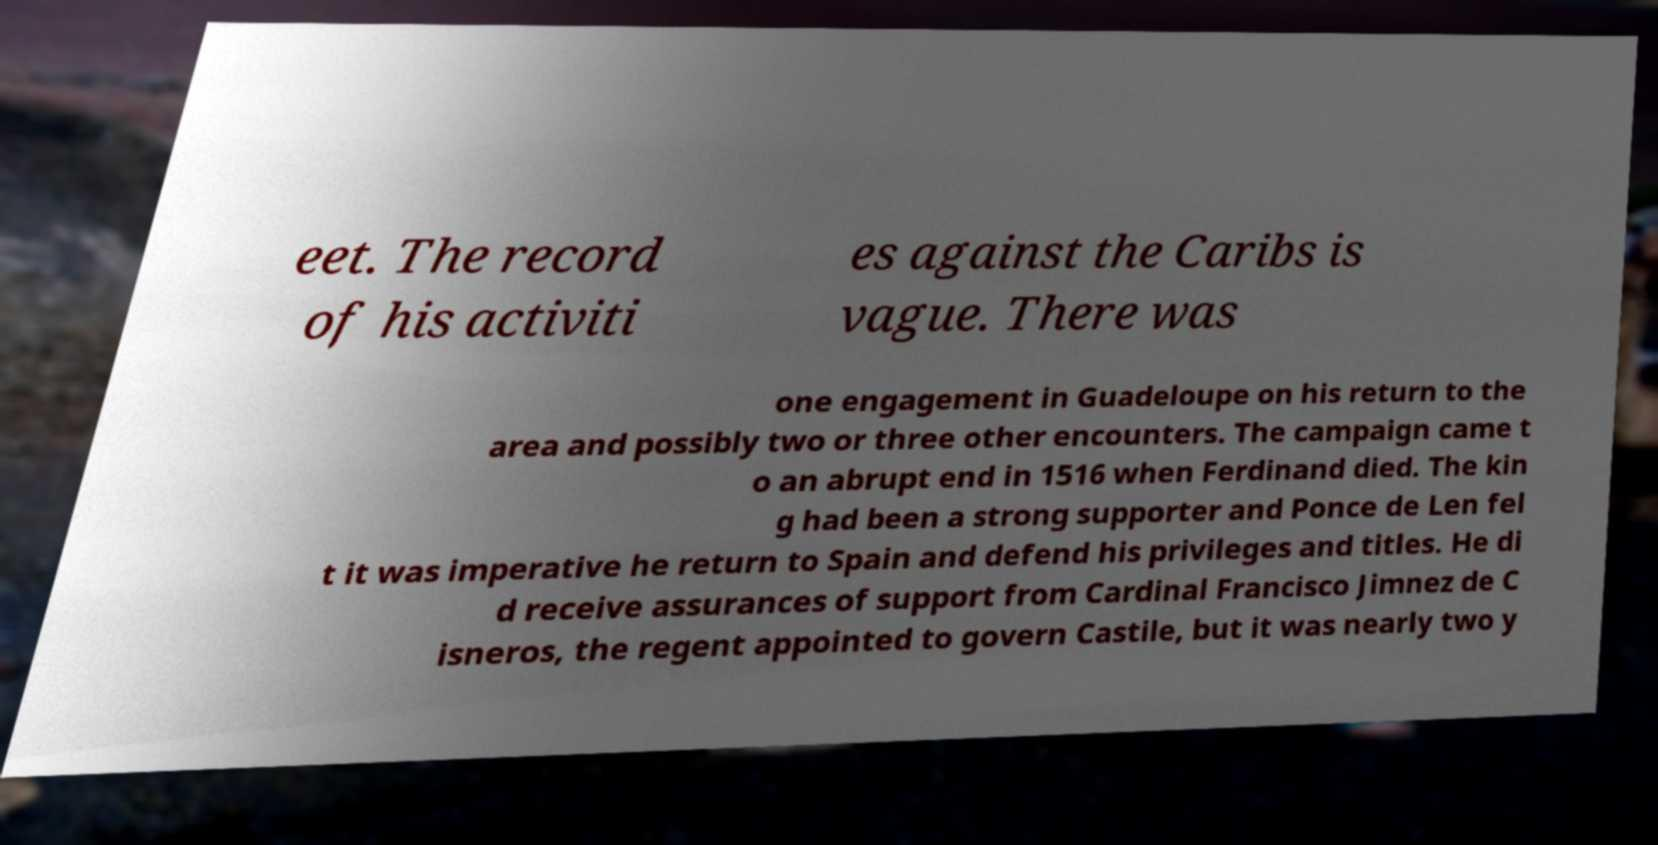Could you assist in decoding the text presented in this image and type it out clearly? eet. The record of his activiti es against the Caribs is vague. There was one engagement in Guadeloupe on his return to the area and possibly two or three other encounters. The campaign came t o an abrupt end in 1516 when Ferdinand died. The kin g had been a strong supporter and Ponce de Len fel t it was imperative he return to Spain and defend his privileges and titles. He di d receive assurances of support from Cardinal Francisco Jimnez de C isneros, the regent appointed to govern Castile, but it was nearly two y 